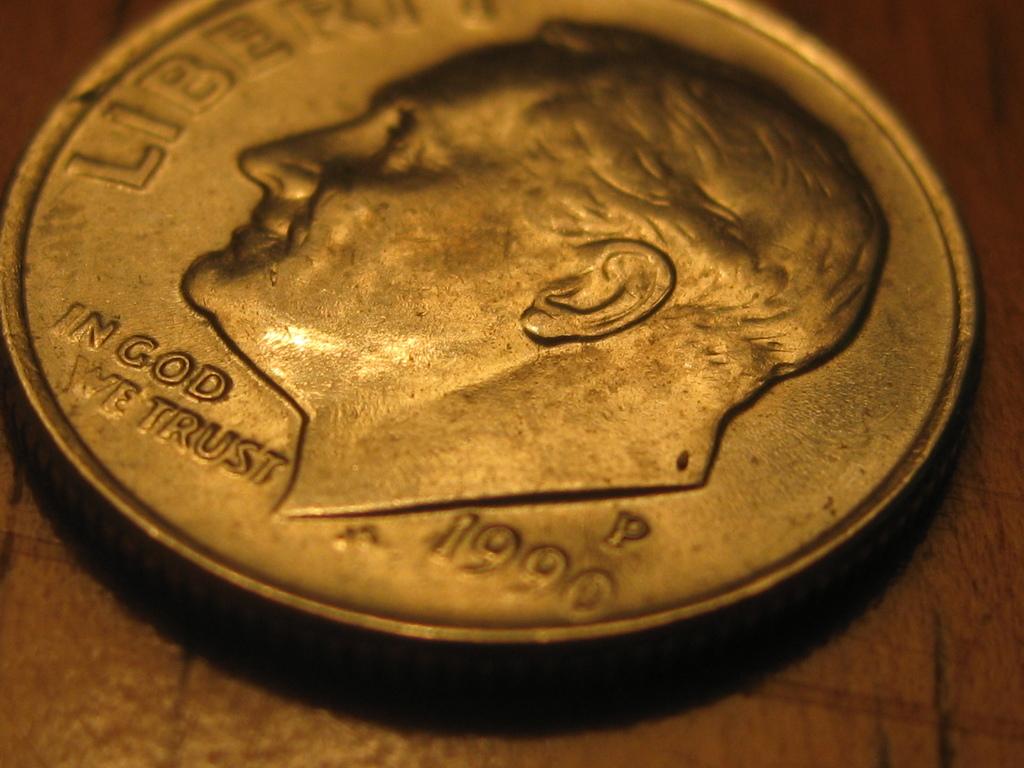In what year was this dime produced?
Make the answer very short. 1990. Was this dime minted in the year 2000?
Keep it short and to the point. No. 